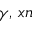<formula> <loc_0><loc_0><loc_500><loc_500>\gamma , \, x n</formula> 